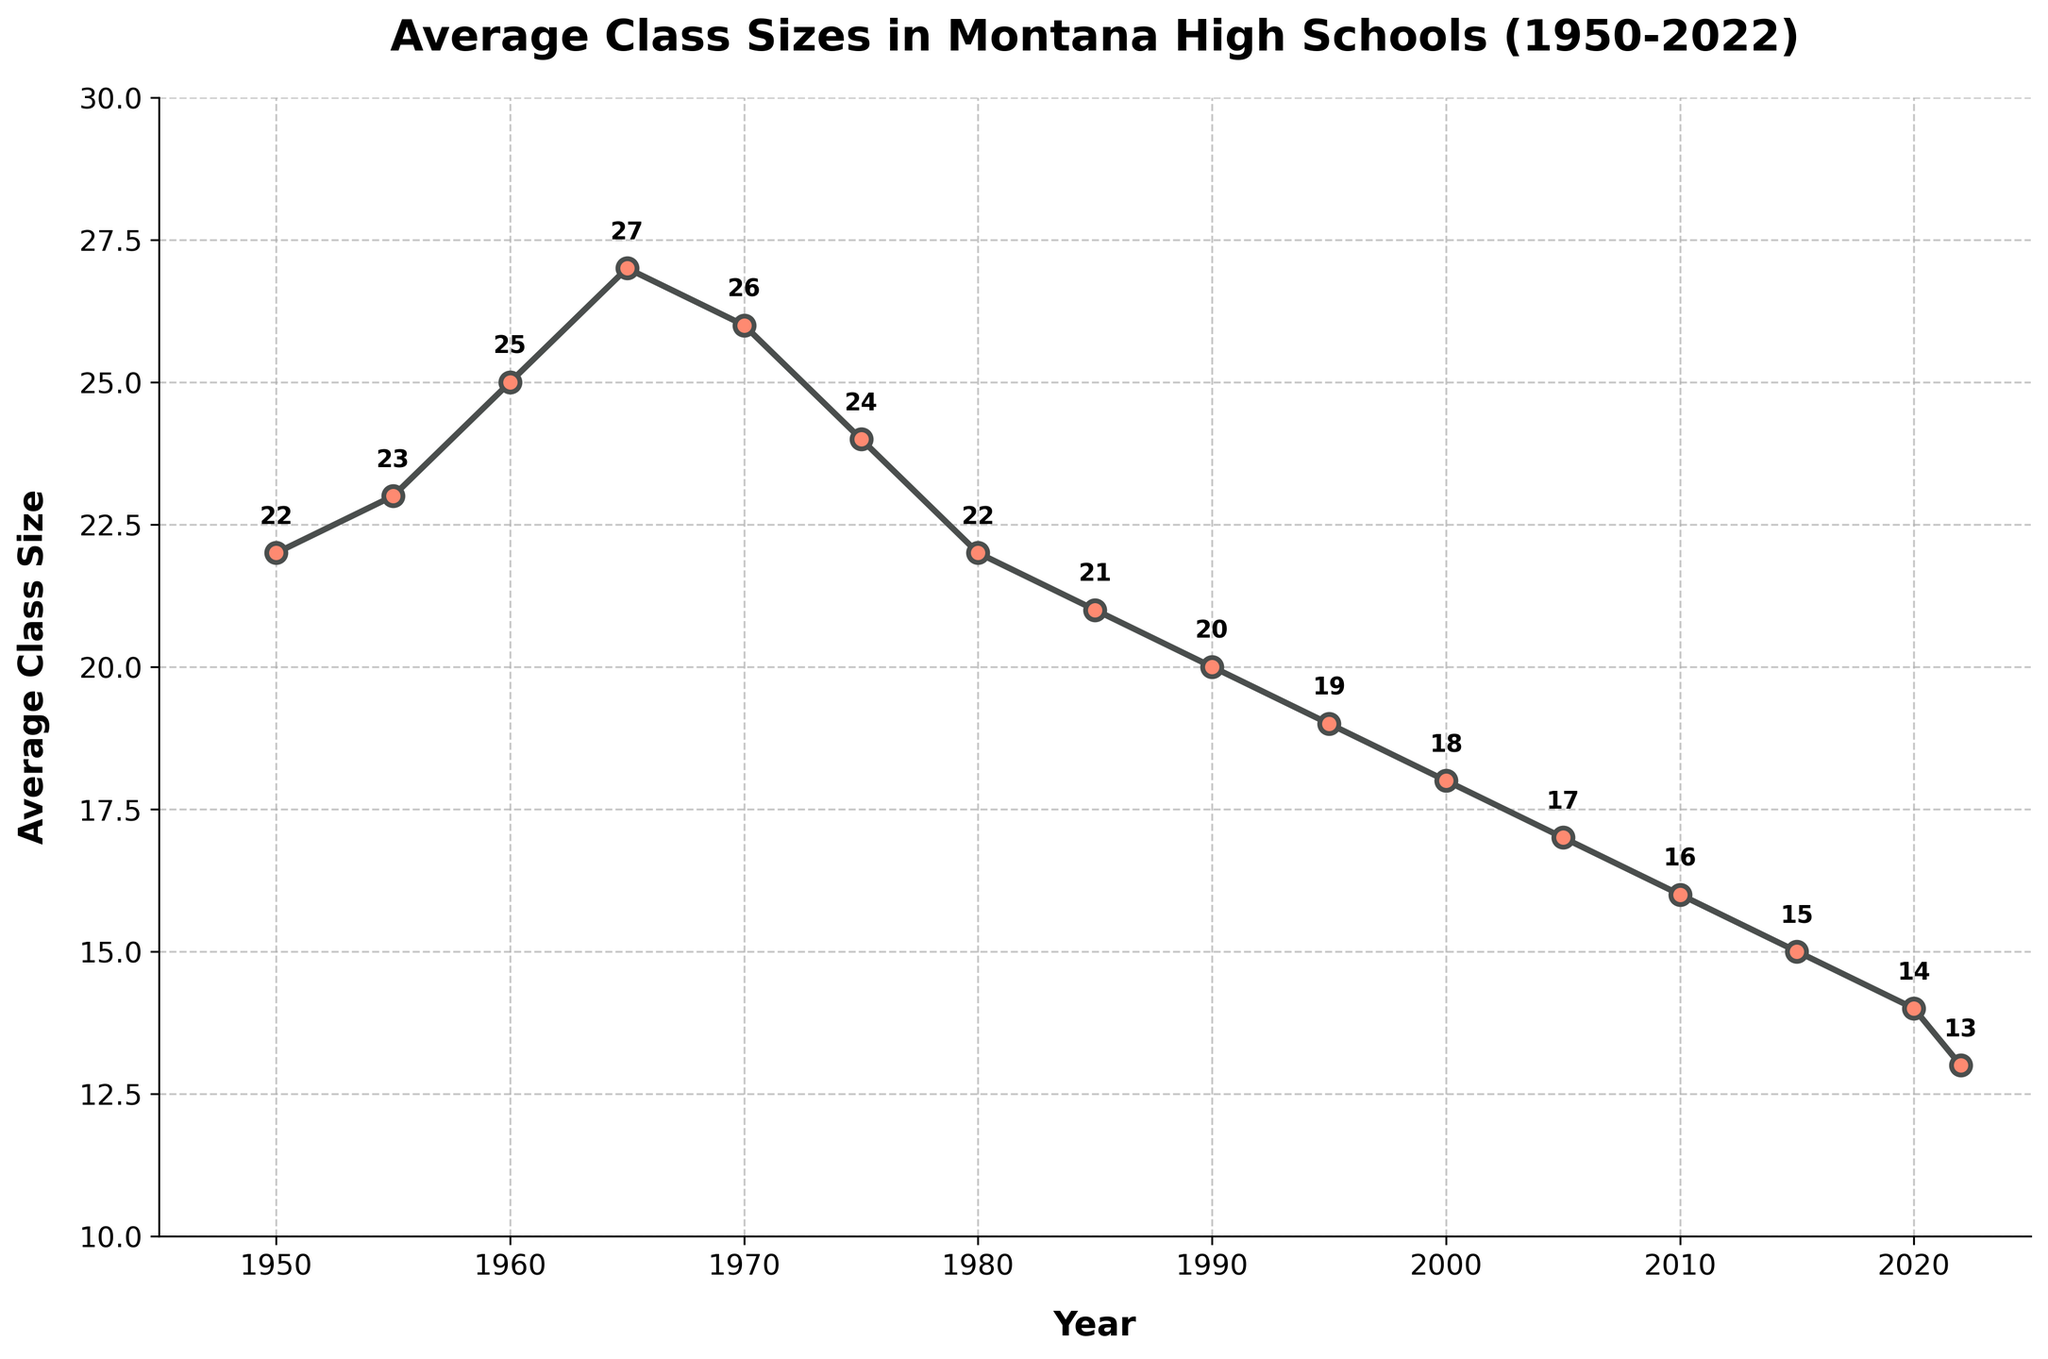What is the average class size in 1950? Check the y-axis data label for the year 1950 on the line chart. The data point shows the class size value next to it.
Answer: 22 By how much did the average class size decrease from 1970 to 2022? Identify the class size values for 1970 (26) and 2022 (13) by checking the data points on the line chart. Subtract 13 from 26.
Answer: 13 How many years did it take for the average class size to decrease from 25 to 20? Locate the class size values for 25 and 20. The class size was 25 in 1960 and 20 in 1990. Subtract 1960 from 1990.
Answer: 30 Which year had the smallest average class size? Identify the data point with the lowest y-axis value. The class size in 2022 is the smallest (13).
Answer: 2022 During which decade did the average class size experience the most significant decrease? Compare the drops in class sizes for each decade by checking the values. The 1990s see the most significant drop from 21 (in 1985) to 14 (in 2020).
Answer: 1990s How does the class size in 1980 compare with the class size in 1950? Check the data point for 1980 (22) and compare it with 1950 (22). The values are equal.
Answer: Equal What's the difference between the highest and lowest average class sizes in the dataset? Identify the highest value (27 in 1965) and the lowest value (13 in 2022). Subtract 13 from 27.
Answer: 14 When was the first time the average class size dropped below 20? Check the data points and find the year when the value is first below 20. That happens in 1995.
Answer: 1995 